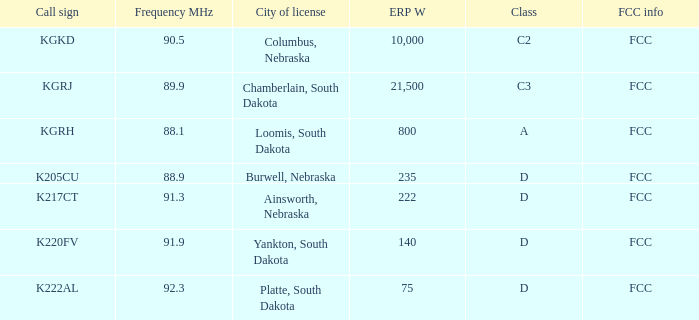What is the complete erp w of class c3, having a frequency mhz lesser than 8 0.0. 